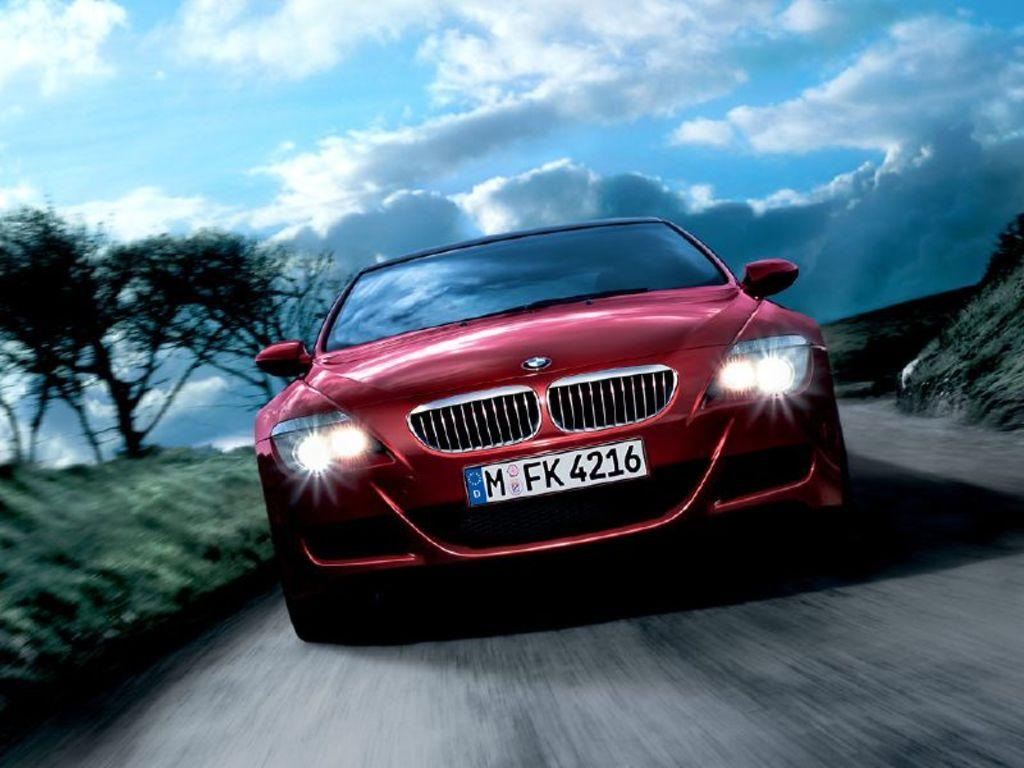What color is the car in the image? The car in the image is red. Where is the car located in the image? The car is on the road in the image. What can be seen on the left side of the image? There are trees on the ground on the left side of the image. What is visible at the top of the image? The sky is visible at the top of the image, and there are clouds in the sky. What feature can be seen on the front of the car? The car has headlights. Can you tell me how many ants are crawling on the car in the image? There are no ants visible on the car in the image. What type of interest does the car have in the image? The image does not provide information about the car's financial interests. 